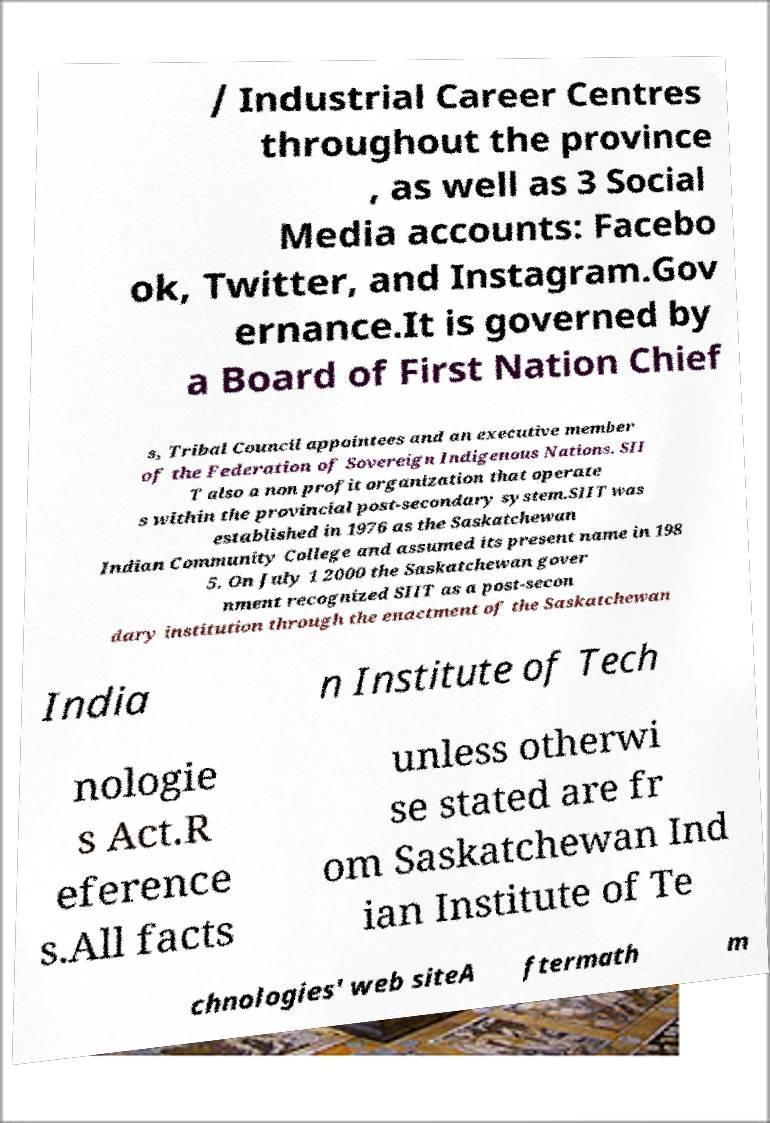Could you extract and type out the text from this image? / Industrial Career Centres throughout the province , as well as 3 Social Media accounts: Facebo ok, Twitter, and Instagram.Gov ernance.It is governed by a Board of First Nation Chief s, Tribal Council appointees and an executive member of the Federation of Sovereign Indigenous Nations. SII T also a non profit organization that operate s within the provincial post-secondary system.SIIT was established in 1976 as the Saskatchewan Indian Community College and assumed its present name in 198 5. On July 1 2000 the Saskatchewan gover nment recognized SIIT as a post-secon dary institution through the enactment of the Saskatchewan India n Institute of Tech nologie s Act.R eference s.All facts unless otherwi se stated are fr om Saskatchewan Ind ian Institute of Te chnologies' web siteA ftermath m 